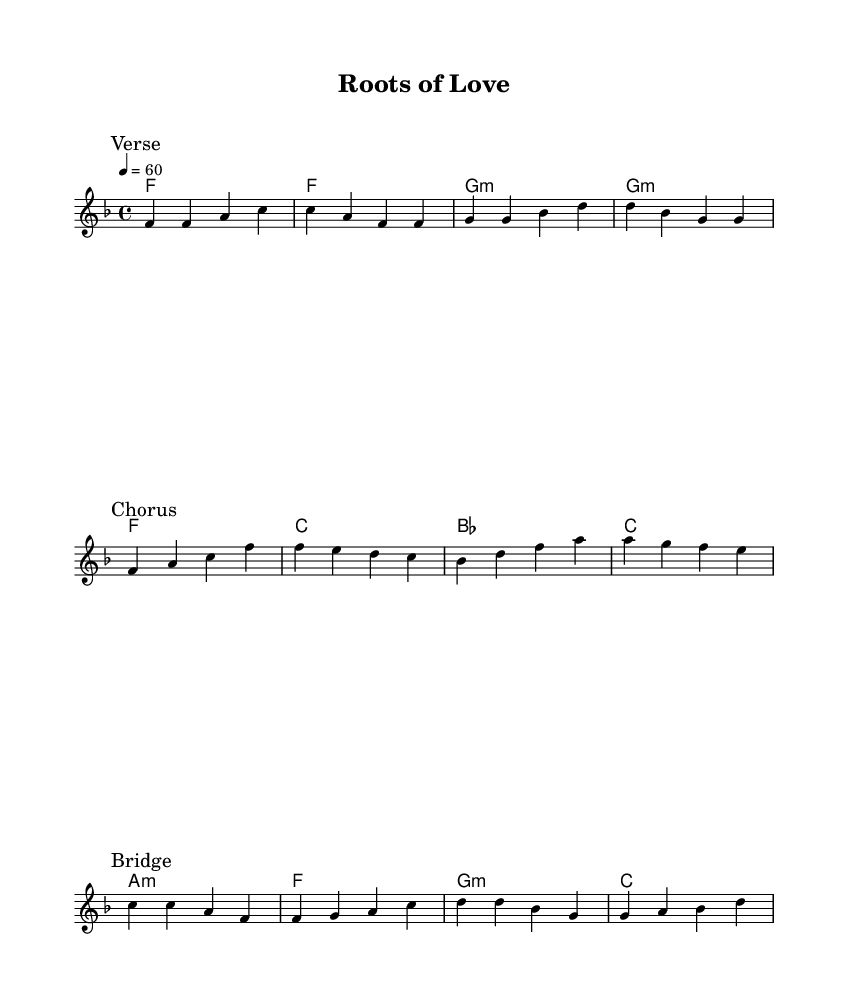What is the key signature of this music? The key signature is F major, which has one flat (B flat). This can be determined by identifying the key signature indicated at the beginning of the score, which shows one flat.
Answer: F major What is the time signature of this piece? The time signature is 4/4, as indicated in the score where it appears at the beginning. It establishes a regular four beats per measure.
Answer: 4/4 What is the tempo marking of this music? The tempo marking is 60, which indicates that there are 60 beats per minute. It is stated at the beginning of the score using the tempo indication.
Answer: 60 How many measures are in the verse section? The verse section contains 4 measures. By counting the lines, each line of music represents 4 measures, and the verse is indicated to have one line of melody.
Answer: 4 What is the second chord in the chorus? The second chord in the chorus is E flat. This can be found by looking at the chord changes indicated alongside the melody in the score, specifically in the section marked "Chorus."
Answer: E flat Which lyric corresponds to the chorus section? The lyric corresponding to the chorus section is "Watch it grow, let it show, the roots of love we share." This can be identified by observing the lyrics aligned with the melody marked in the chorus section of the score.
Answer: Watch it grow, let it show, the roots of love we share What is the bridge section's first note? The first note of the bridge section is C. This can be identified at the beginning of the bridge where the melody starts, marked with "Bridge."
Answer: C 